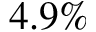<formula> <loc_0><loc_0><loc_500><loc_500>4 . 9 \%</formula> 